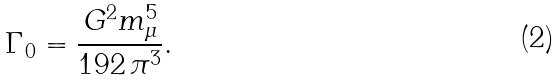<formula> <loc_0><loc_0><loc_500><loc_500>\Gamma _ { 0 } = \frac { G ^ { 2 } m ^ { 5 } _ { \mu } } { 1 9 2 \, \pi ^ { 3 } } .</formula> 